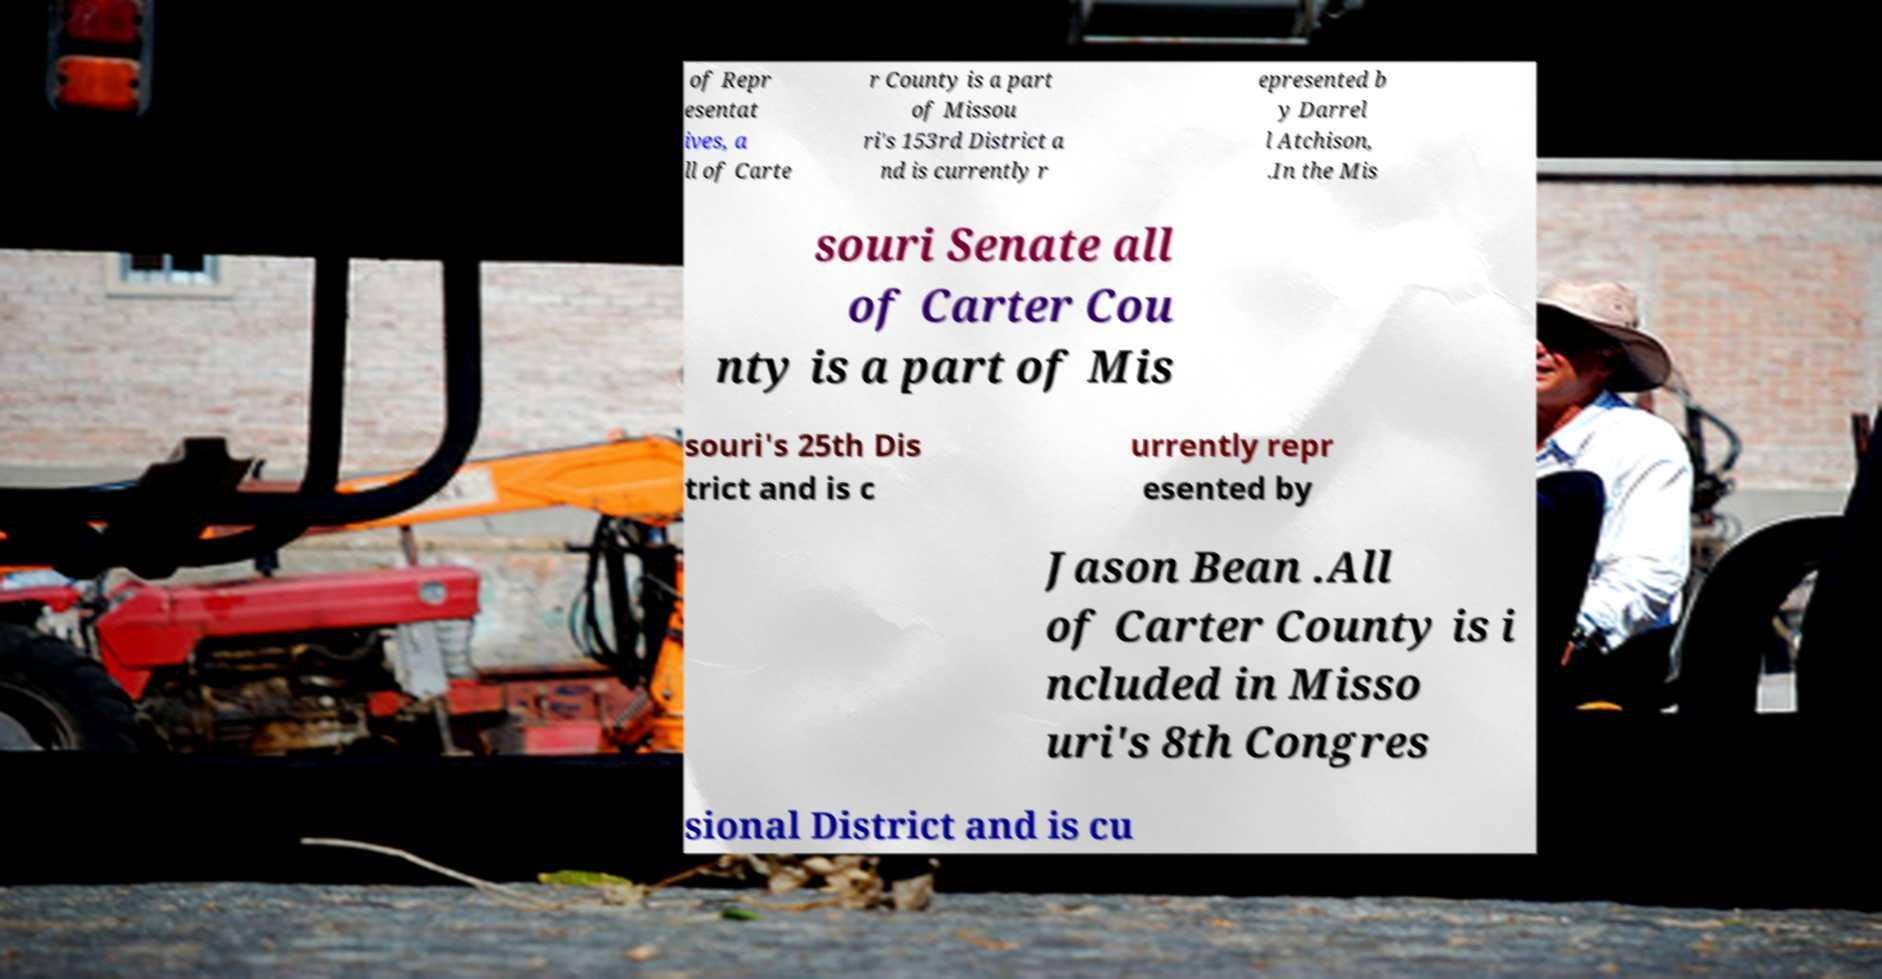Please identify and transcribe the text found in this image. of Repr esentat ives, a ll of Carte r County is a part of Missou ri's 153rd District a nd is currently r epresented b y Darrel l Atchison, .In the Mis souri Senate all of Carter Cou nty is a part of Mis souri's 25th Dis trict and is c urrently repr esented by Jason Bean .All of Carter County is i ncluded in Misso uri's 8th Congres sional District and is cu 